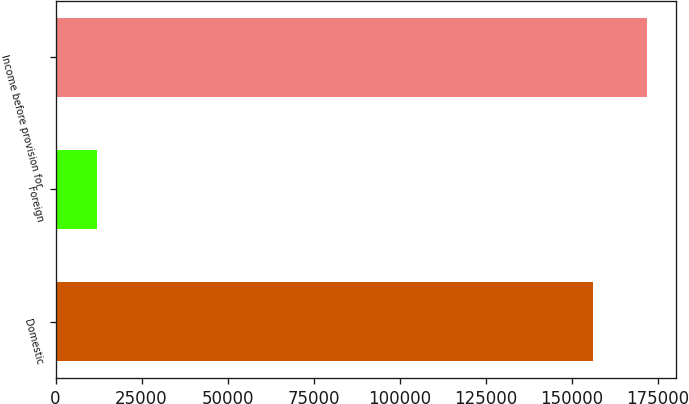<chart> <loc_0><loc_0><loc_500><loc_500><bar_chart><fcel>Domestic<fcel>Foreign<fcel>Income before provision for<nl><fcel>156219<fcel>11986<fcel>171841<nl></chart> 